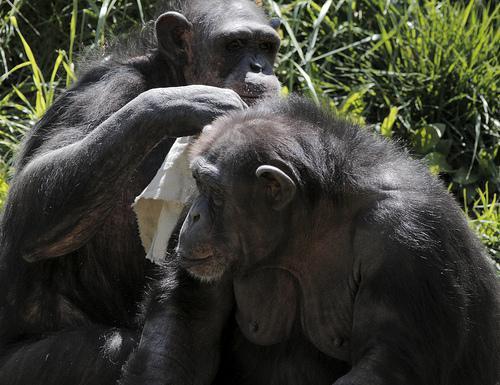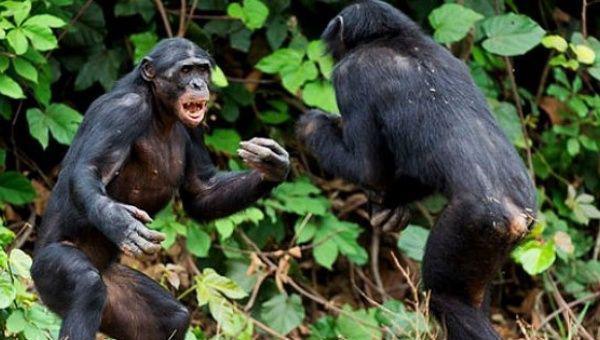The first image is the image on the left, the second image is the image on the right. Examine the images to the left and right. Is the description "There are four monkeys." accurate? Answer yes or no. Yes. The first image is the image on the left, the second image is the image on the right. Given the left and right images, does the statement "Each image contains a pair of chimps posed near each other, and no chimps are young babies." hold true? Answer yes or no. Yes. 